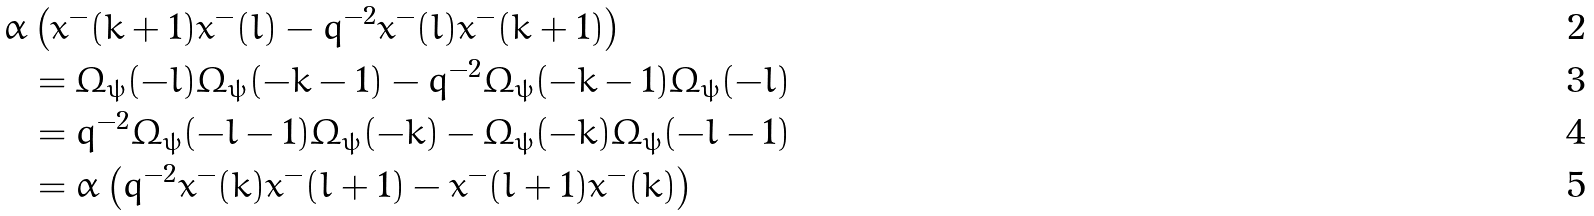Convert formula to latex. <formula><loc_0><loc_0><loc_500><loc_500>\bar { \alpha } & \left ( x ^ { - } ( k + 1 ) x ^ { - } ( l ) - q ^ { - 2 } x ^ { - } ( l ) x ^ { - } ( k + 1 ) \right ) \\ & = \Omega _ { \psi } ( - l ) \Omega _ { \psi } ( - k - 1 ) - q ^ { - 2 } \Omega _ { \psi } ( - k - 1 ) \Omega _ { \psi } ( - l ) \\ & = q ^ { - 2 } \Omega _ { \psi } ( - l - 1 ) \Omega _ { \psi } ( - k ) - \Omega _ { \psi } ( - k ) \Omega _ { \psi } ( - l - 1 ) \\ & = \bar { \alpha } \left ( q ^ { - 2 } x ^ { - } ( k ) x ^ { - } ( l + 1 ) - x ^ { - } ( l + 1 ) x ^ { - } ( k ) \right )</formula> 